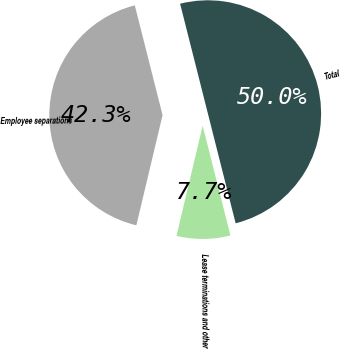<chart> <loc_0><loc_0><loc_500><loc_500><pie_chart><fcel>Employee separations<fcel>Lease terminations and other<fcel>Total<nl><fcel>42.34%<fcel>7.66%<fcel>50.0%<nl></chart> 